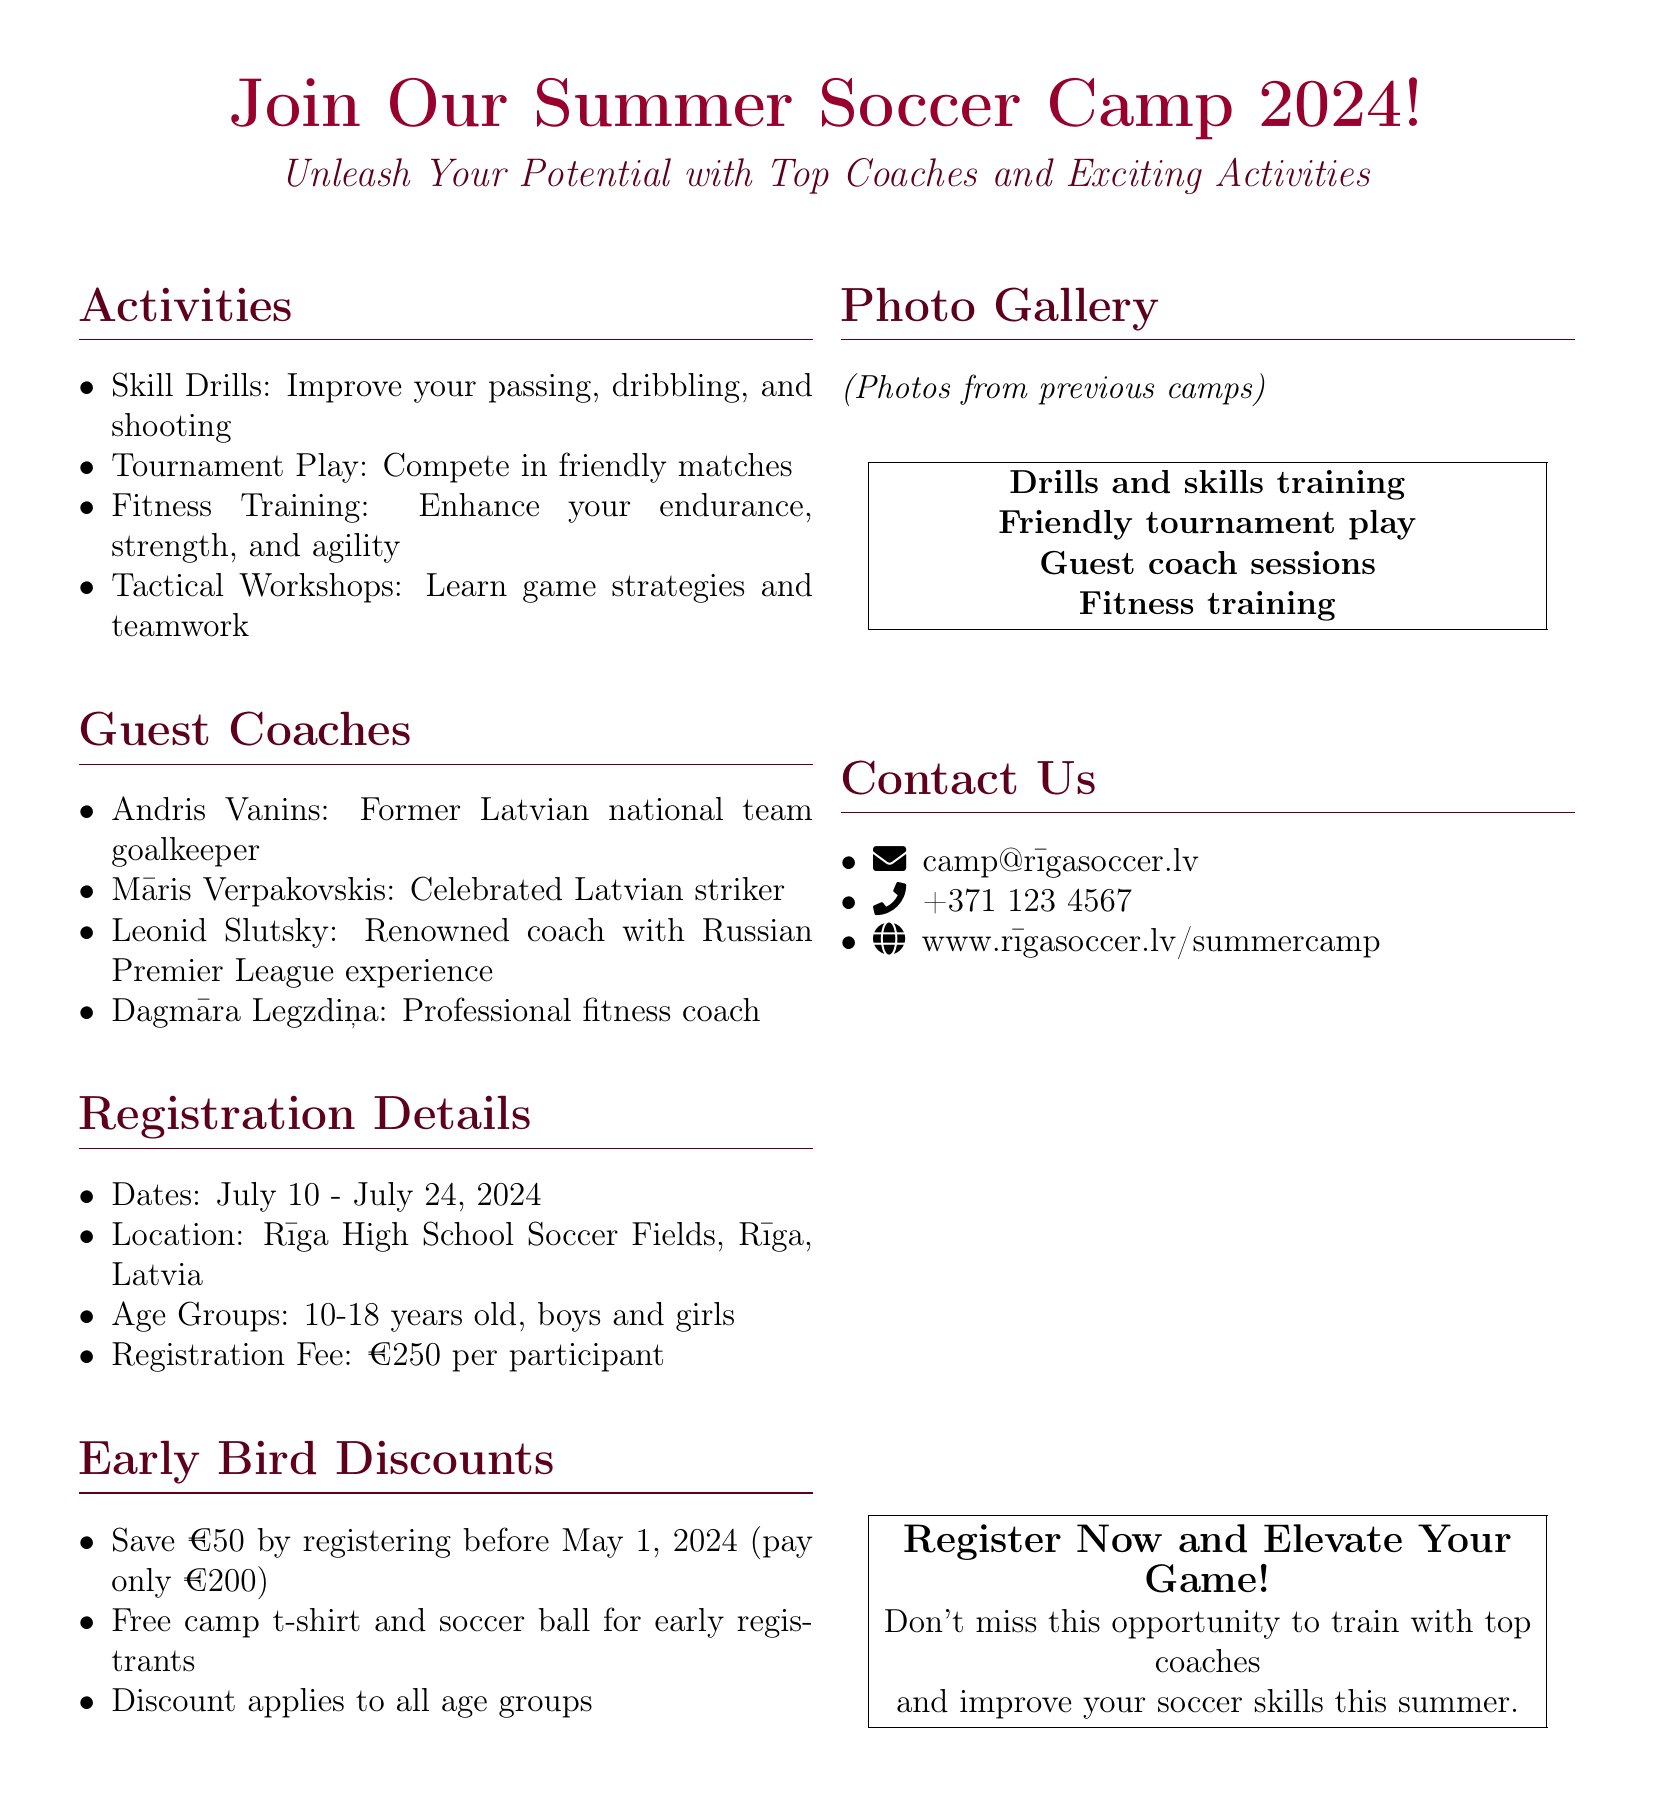What are the camp dates? The camp dates are specified as July 10 - July 24, 2024.
Answer: July 10 - July 24, 2024 Who is one of the guest coaches? The document lists several guest coaches, including Andris Vanins.
Answer: Andris Vanins What is the age range for participants? The document specifies the age groups for the camp as 10-18 years old.
Answer: 10-18 years old What is the registration fee? The document states the registration fee is €250 per participant.
Answer: €250 What discount is offered for early registration? The document mentions a €50 discount for early registration before May 1, 2024.
Answer: €50 What is included for early registrants? The document states that early registrants receive a free camp t-shirt and soccer ball.
Answer: Free camp t-shirt and soccer ball Where is the camp location? The document specifies the location as Rīga High School Soccer Fields, Rīga, Latvia.
Answer: Rīga High School Soccer Fields, Rīga, Latvia How many guest coaches are listed in the document? The document lists four guest coaches in total.
Answer: Four What type of activities are offered at the camp? The document outlines several activities, including skill drills and fitness training.
Answer: Skill drills and fitness training What is the contact email for the camp? The document provides the email address for contact as camp@rīgasoccer.lv.
Answer: camp@rīgasoccer.lv 